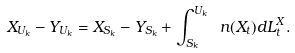Convert formula to latex. <formula><loc_0><loc_0><loc_500><loc_500>X _ { U _ { k } } - Y _ { U _ { k } } = X _ { S _ { k } } - Y _ { S _ { k } } + \int _ { S _ { k } } ^ { U _ { k } } \ n ( X _ { t } ) d L ^ { X } _ { t } .</formula> 